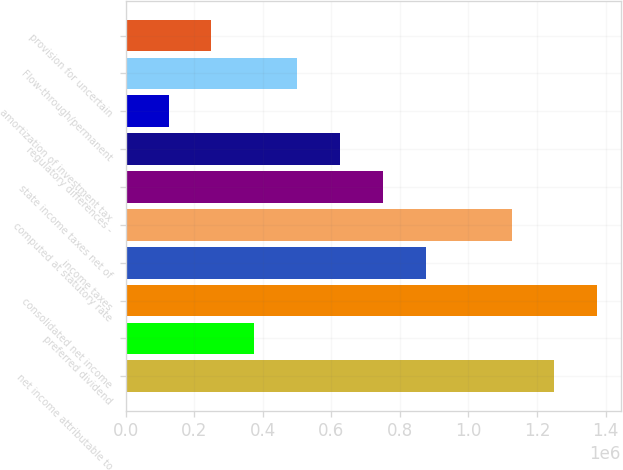Convert chart. <chart><loc_0><loc_0><loc_500><loc_500><bar_chart><fcel>net income attributable to<fcel>preferred dividend<fcel>consolidated net income<fcel>income taxes<fcel>computed at statutory rate<fcel>state income taxes net of<fcel>regulatory differences -<fcel>amortization of investment tax<fcel>Flow-through/permanent<fcel>provision for uncertain<nl><fcel>1.25105e+06<fcel>375339<fcel>1.37615e+06<fcel>875745<fcel>1.12595e+06<fcel>750643<fcel>625542<fcel>125135<fcel>500440<fcel>250237<nl></chart> 